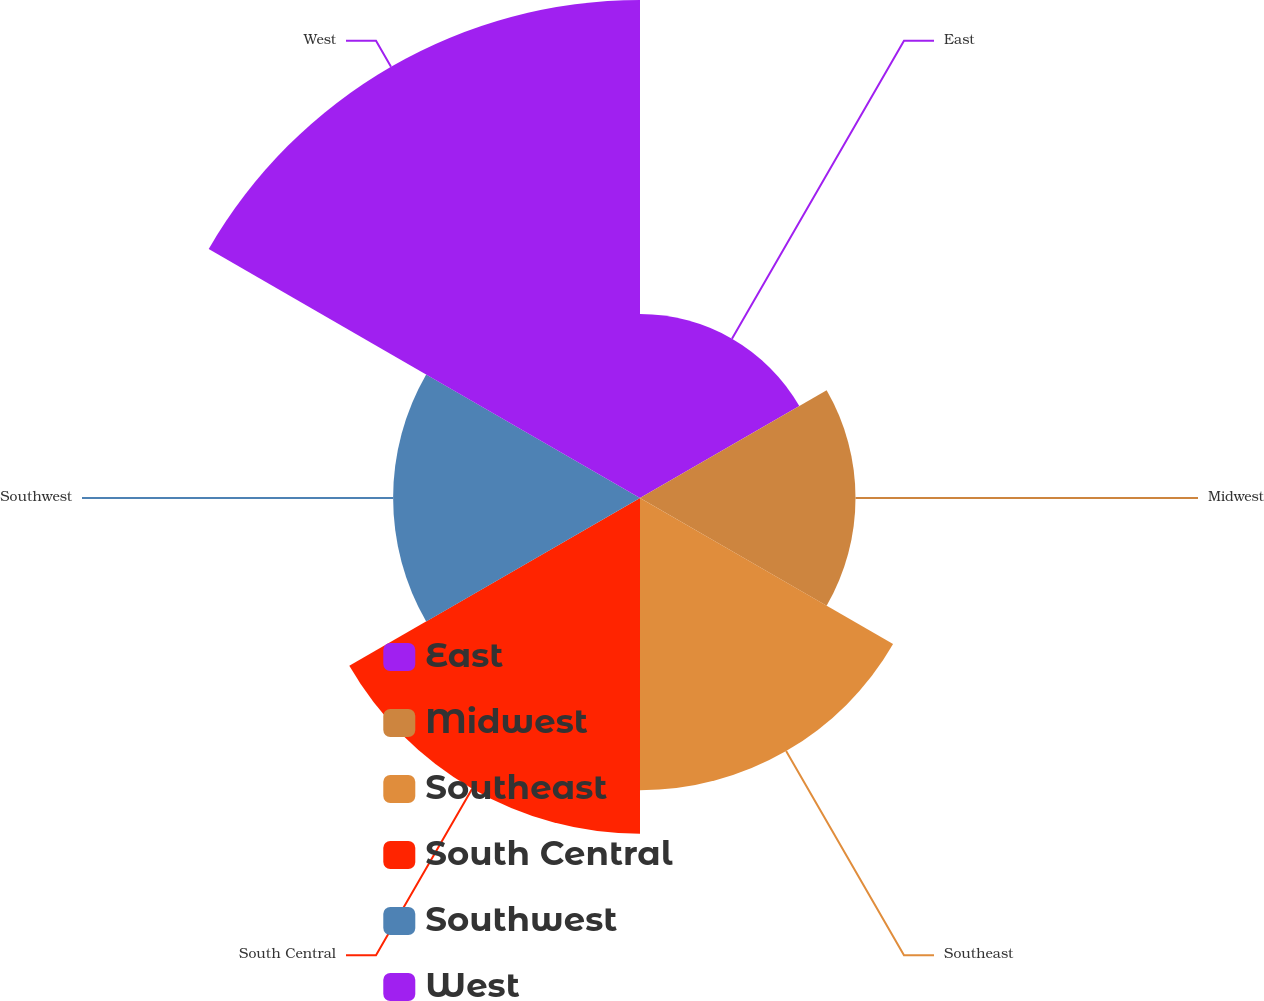<chart> <loc_0><loc_0><loc_500><loc_500><pie_chart><fcel>East<fcel>Midwest<fcel>Southeast<fcel>South Central<fcel>Southwest<fcel>West<nl><fcel>10.38%<fcel>12.16%<fcel>16.49%<fcel>18.94%<fcel>13.93%<fcel>28.1%<nl></chart> 